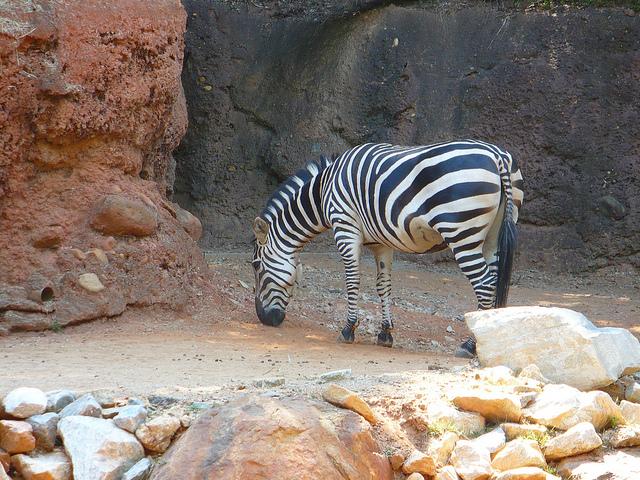Is this picture taken in the wild?
Short answer required. No. What is unnatural about this animal's setting?
Be succinct. Rocks. What is this animal?
Quick response, please. Zebra. 